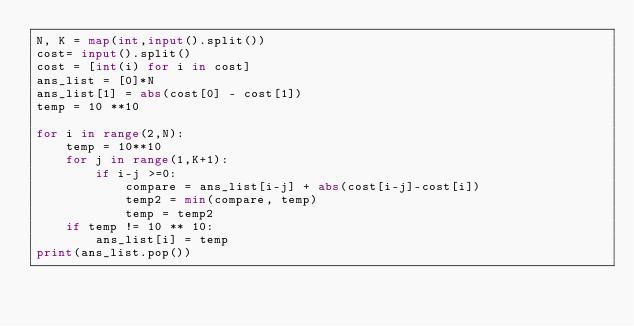<code> <loc_0><loc_0><loc_500><loc_500><_Python_>N, K = map(int,input().split())
cost= input().split()
cost = [int(i) for i in cost]
ans_list = [0]*N
ans_list[1] = abs(cost[0] - cost[1])
temp = 10 **10

for i in range(2,N):
    temp = 10**10
    for j in range(1,K+1):
        if i-j >=0:
            compare = ans_list[i-j] + abs(cost[i-j]-cost[i])
            temp2 = min(compare, temp)
            temp = temp2
    if temp != 10 ** 10:
        ans_list[i] = temp
print(ans_list.pop())
</code> 